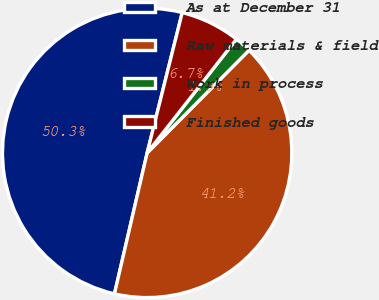Convert chart. <chart><loc_0><loc_0><loc_500><loc_500><pie_chart><fcel>As at December 31<fcel>Raw materials & field<fcel>Work in process<fcel>Finished goods<nl><fcel>50.27%<fcel>41.19%<fcel>1.85%<fcel>6.69%<nl></chart> 